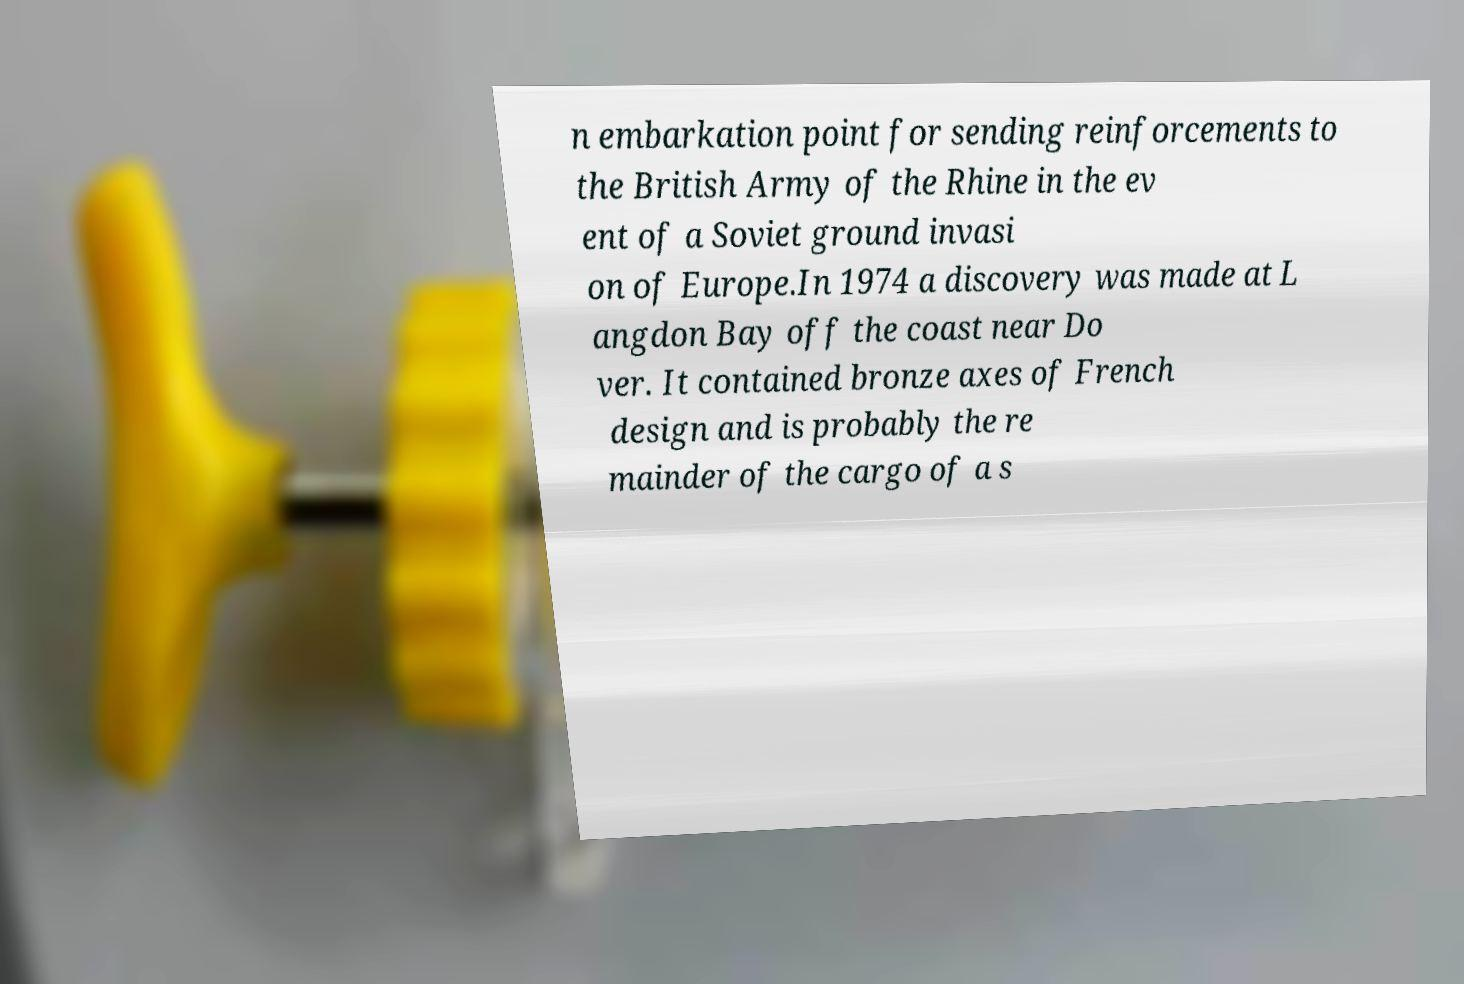I need the written content from this picture converted into text. Can you do that? n embarkation point for sending reinforcements to the British Army of the Rhine in the ev ent of a Soviet ground invasi on of Europe.In 1974 a discovery was made at L angdon Bay off the coast near Do ver. It contained bronze axes of French design and is probably the re mainder of the cargo of a s 